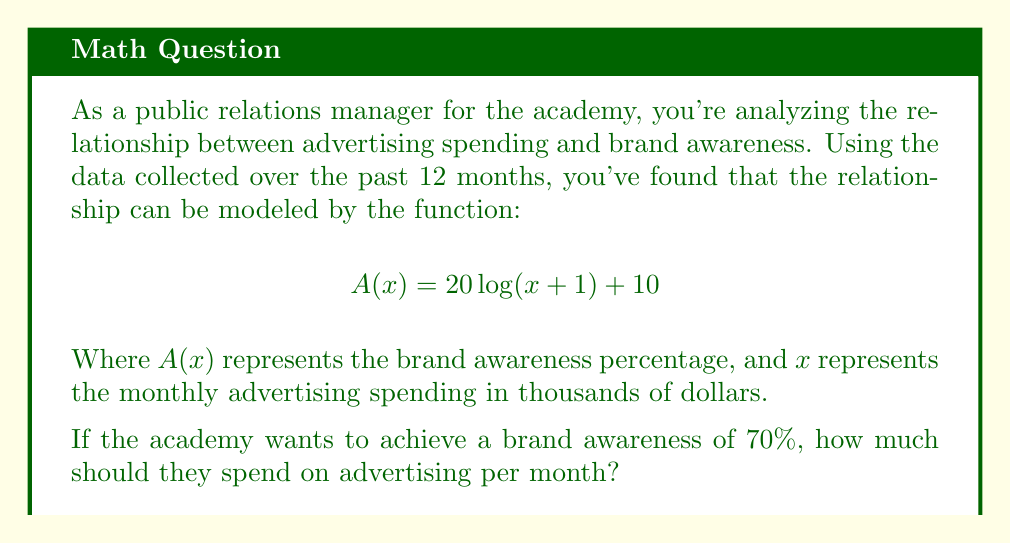Give your solution to this math problem. To solve this problem, we need to follow these steps:

1) We're given the function $A(x) = 20\log(x+1) + 10$, where $A(x)$ is the brand awareness percentage and $x$ is the monthly advertising spending in thousands of dollars.

2) We want to find $x$ when $A(x) = 70$. So, we need to solve the equation:

   $$70 = 20\log(x+1) + 10$$

3) First, subtract 10 from both sides:

   $$60 = 20\log(x+1)$$

4) Now, divide both sides by 20:

   $$3 = \log(x+1)$$

5) To isolate $x$, we need to apply the inverse function of logarithm, which is exponential. Apply $e^x$ to both sides:

   $$e^3 = e^{\log(x+1)}$$

6) The left side simplifies to $e^3$, and on the right side, $e$ and $\log$ cancel out:

   $$e^3 = x+1$$

7) Subtract 1 from both sides:

   $$e^3 - 1 = x$$

8) Calculate the value of $e^3 - 1$:

   $$x \approx 19.086$$

9) Remember that $x$ represents thousands of dollars, so we need to multiply by 1000:

   $$19.086 * 1000 = 19,086$$

Therefore, the academy should spend approximately $19,086 per month on advertising to achieve 70% brand awareness.
Answer: $19,086 